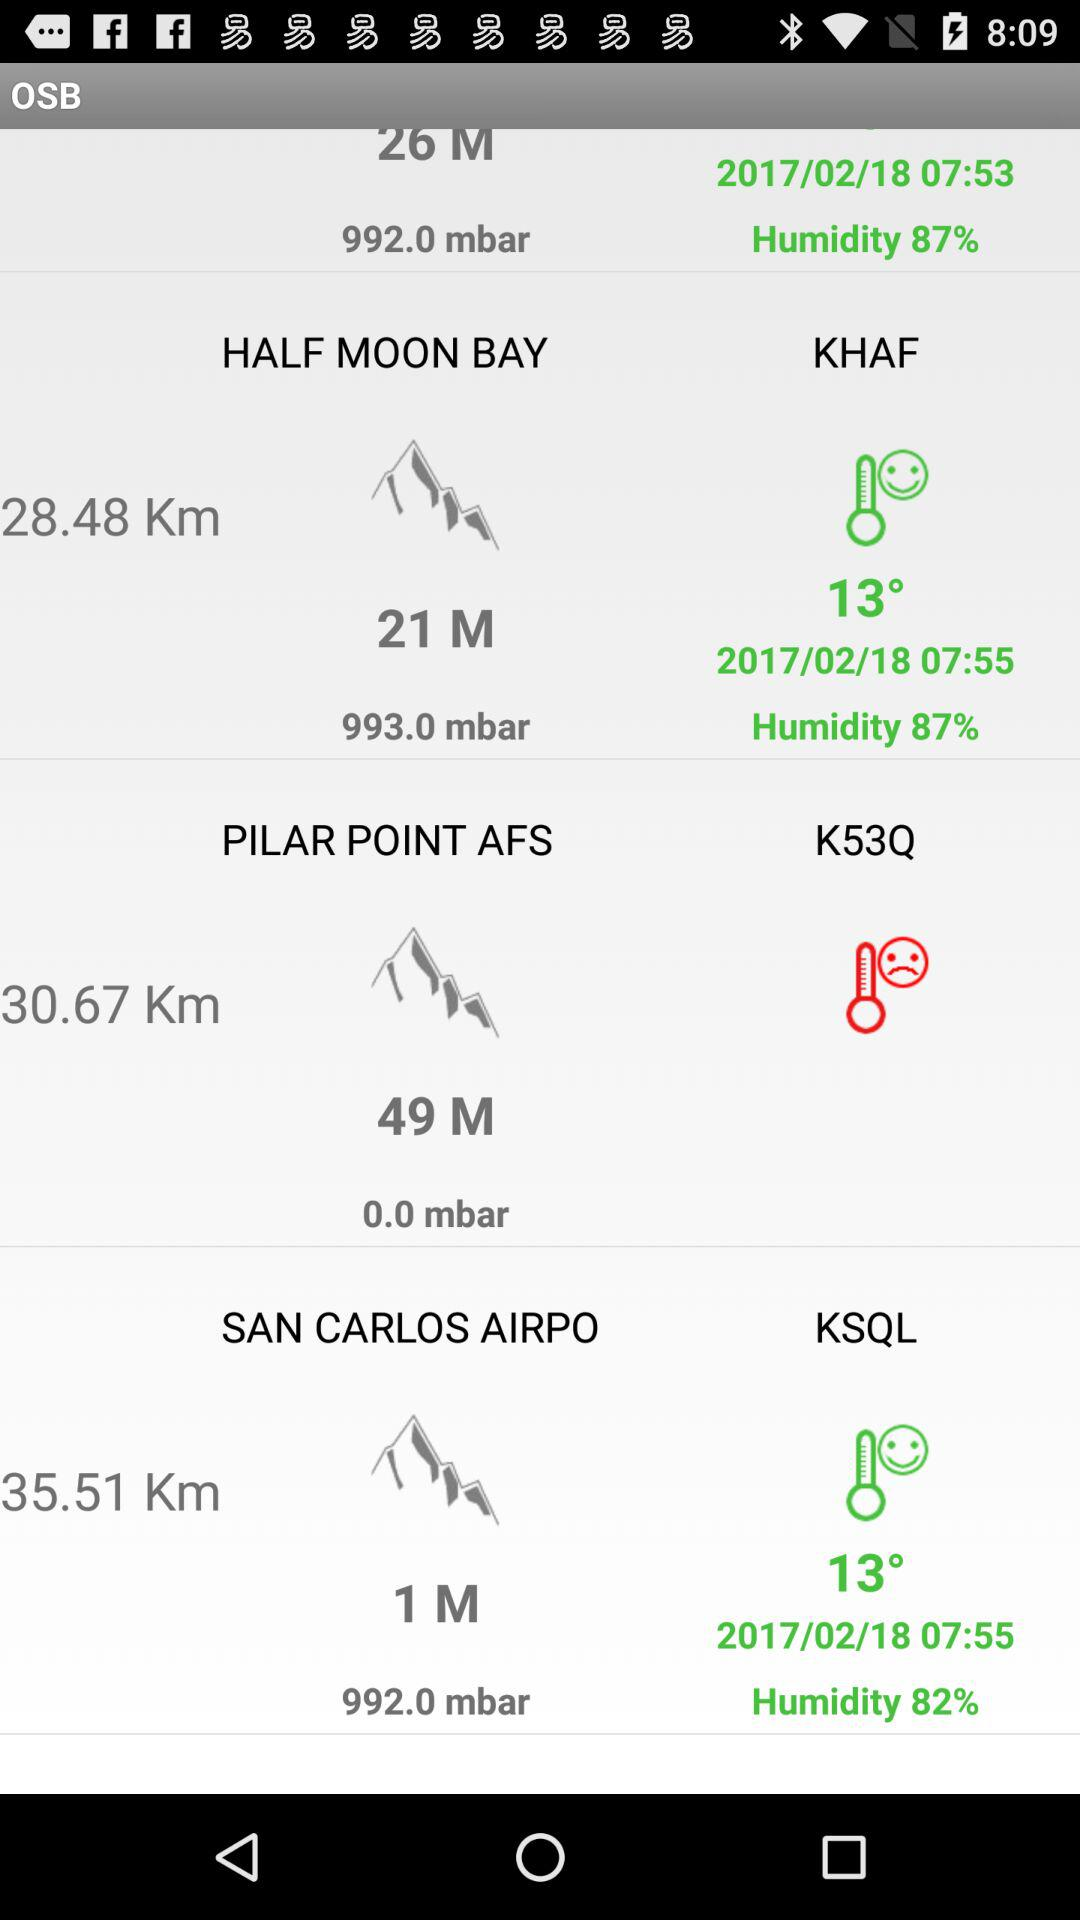What is the temperature of Half Moon Bay? The temperature is 13 degrees. 